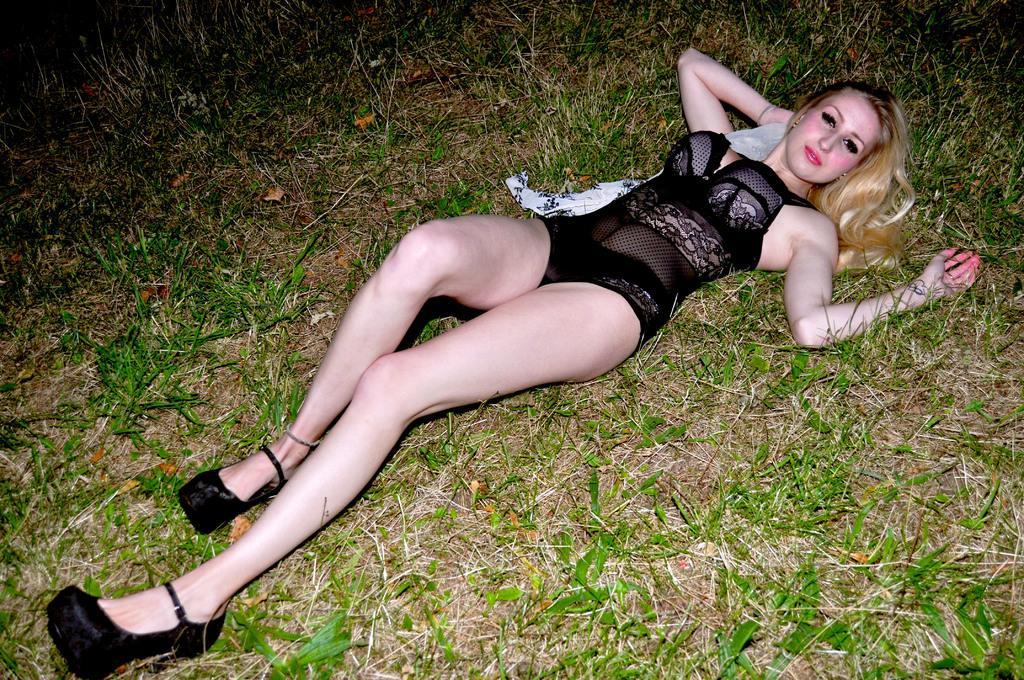Please provide a concise description of this image. In this image I can see a person sleeping and wearing black color dress. I can see the green grass and dry grass. 